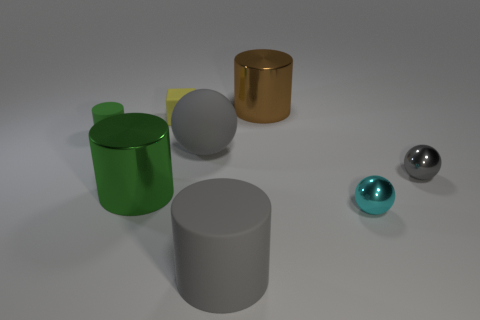Add 1 brown shiny cubes. How many objects exist? 9 Subtract all blue cylinders. Subtract all blue blocks. How many cylinders are left? 4 Subtract all cubes. How many objects are left? 7 Add 7 large brown metallic cylinders. How many large brown metallic cylinders are left? 8 Add 8 purple spheres. How many purple spheres exist? 8 Subtract 0 brown balls. How many objects are left? 8 Subtract all spheres. Subtract all large gray shiny cylinders. How many objects are left? 5 